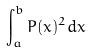Convert formula to latex. <formula><loc_0><loc_0><loc_500><loc_500>\int _ { a } ^ { b } P ( x ) ^ { 2 } d x</formula> 